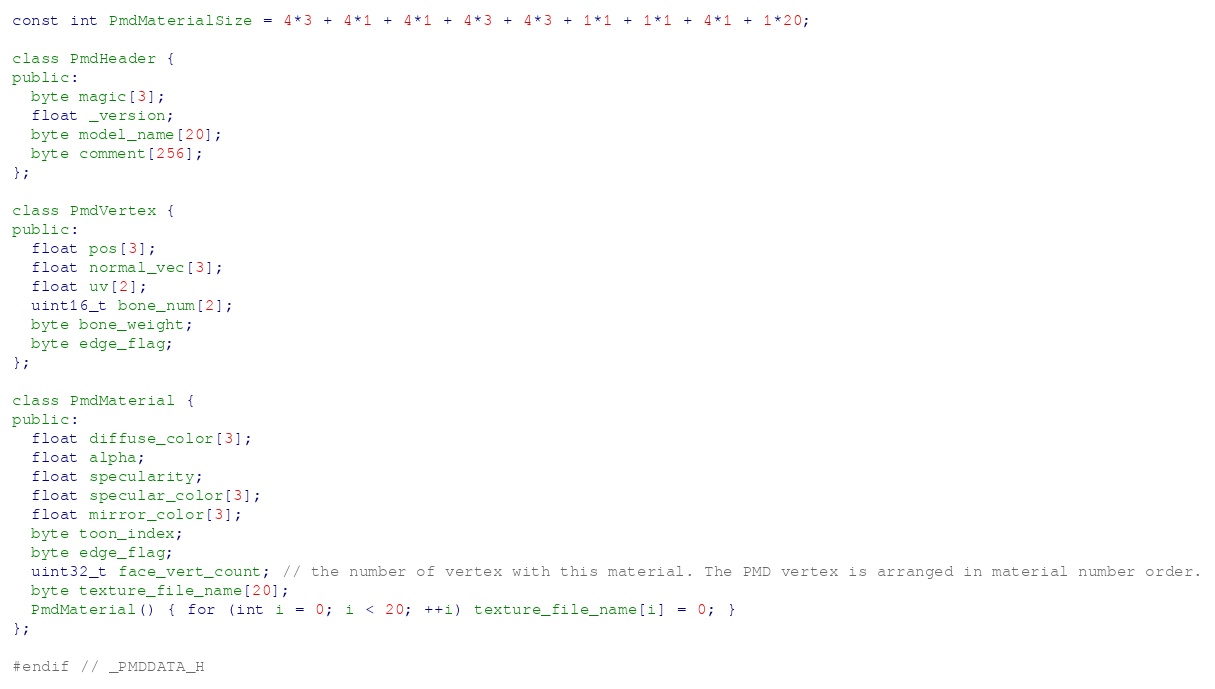<code> <loc_0><loc_0><loc_500><loc_500><_C_>const int PmdMaterialSize = 4*3 + 4*1 + 4*1 + 4*3 + 4*3 + 1*1 + 1*1 + 4*1 + 1*20;

class PmdHeader {
public:
  byte magic[3];
  float _version;
  byte model_name[20];
  byte comment[256];
};

class PmdVertex {
public: 
  float pos[3];
  float normal_vec[3];
  float uv[2];
  uint16_t bone_num[2];
  byte bone_weight;
  byte edge_flag;
};

class PmdMaterial {
public:
  float diffuse_color[3];
  float alpha;
  float specularity;
  float specular_color[3];
  float mirror_color[3];
  byte toon_index;
  byte edge_flag;
  uint32_t face_vert_count; // the number of vertex with this material. The PMD vertex is arranged in material number order.
  byte texture_file_name[20];
  PmdMaterial() { for (int i = 0; i < 20; ++i) texture_file_name[i] = 0; }
};

#endif // _PMDDATA_H
</code> 